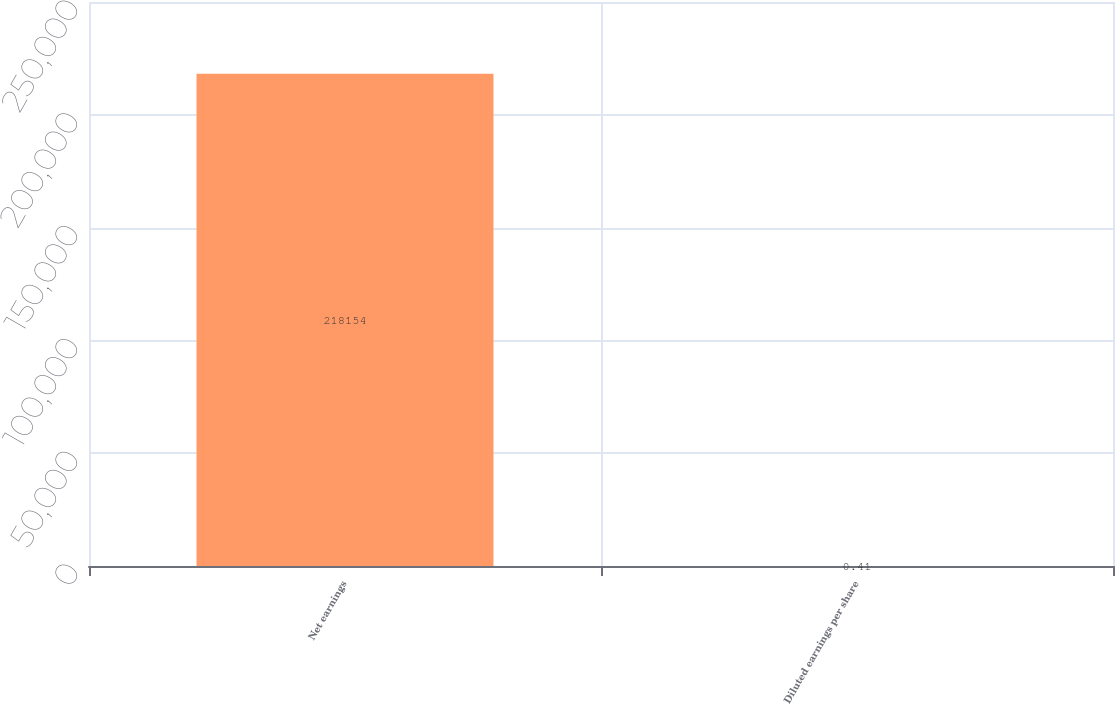Convert chart to OTSL. <chart><loc_0><loc_0><loc_500><loc_500><bar_chart><fcel>Net earnings<fcel>Diluted earnings per share<nl><fcel>218154<fcel>0.41<nl></chart> 